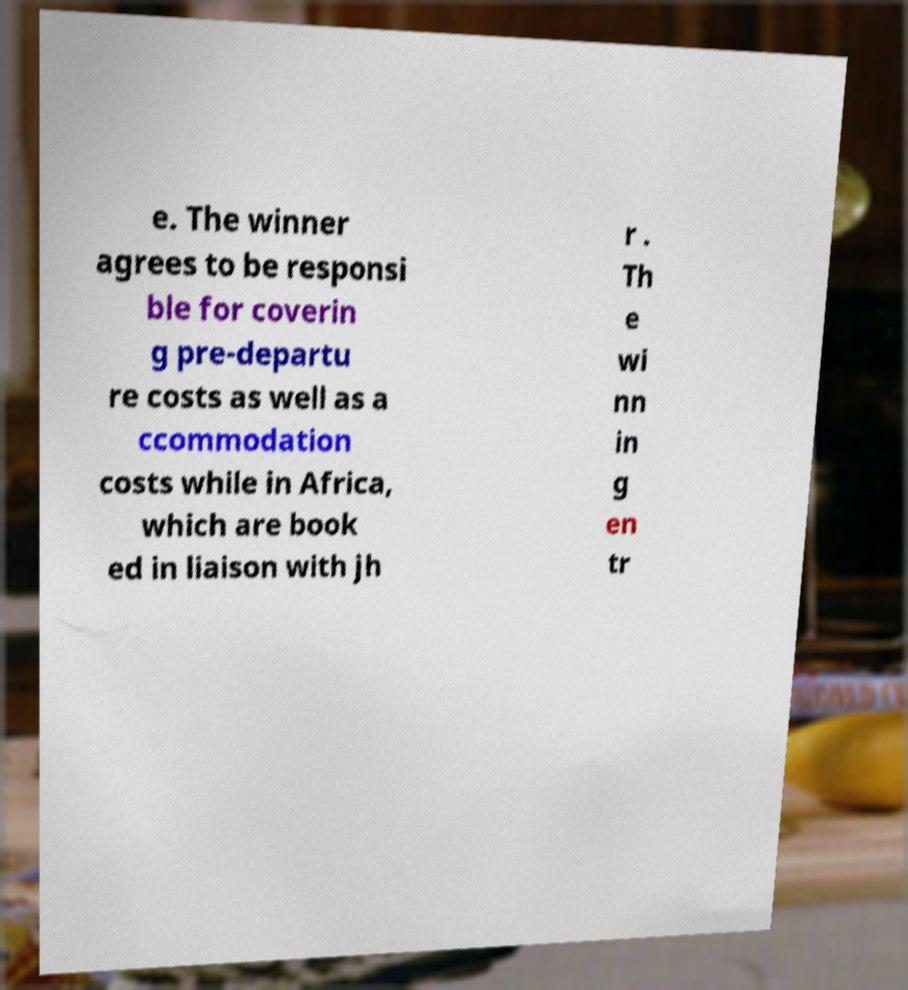Please read and relay the text visible in this image. What does it say? e. The winner agrees to be responsi ble for coverin g pre-departu re costs as well as a ccommodation costs while in Africa, which are book ed in liaison with jh r . Th e wi nn in g en tr 